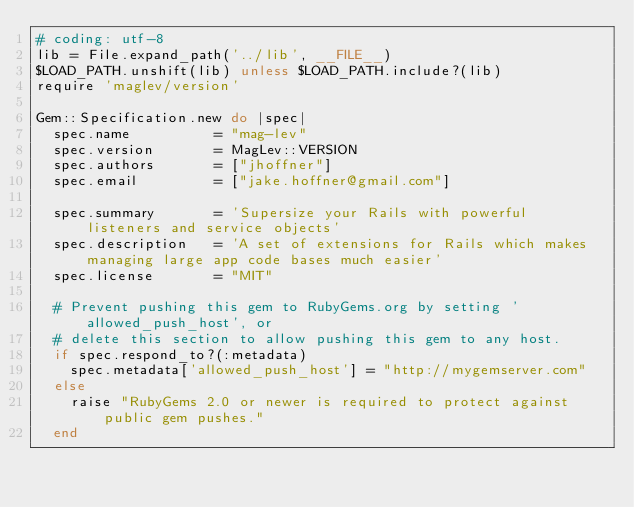<code> <loc_0><loc_0><loc_500><loc_500><_Ruby_># coding: utf-8
lib = File.expand_path('../lib', __FILE__)
$LOAD_PATH.unshift(lib) unless $LOAD_PATH.include?(lib)
require 'maglev/version'

Gem::Specification.new do |spec|
  spec.name          = "mag-lev"
  spec.version       = MagLev::VERSION
  spec.authors       = ["jhoffner"]
  spec.email         = ["jake.hoffner@gmail.com"]

  spec.summary       = 'Supersize your Rails with powerful listeners and service objects'
  spec.description   = 'A set of extensions for Rails which makes managing large app code bases much easier'
  spec.license       = "MIT"

  # Prevent pushing this gem to RubyGems.org by setting 'allowed_push_host', or
  # delete this section to allow pushing this gem to any host.
  if spec.respond_to?(:metadata)
    spec.metadata['allowed_push_host'] = "http://mygemserver.com"
  else
    raise "RubyGems 2.0 or newer is required to protect against public gem pushes."
  end
</code> 